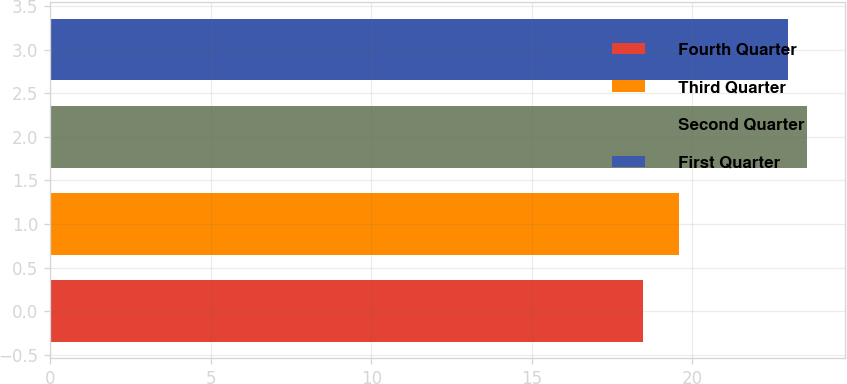Convert chart to OTSL. <chart><loc_0><loc_0><loc_500><loc_500><bar_chart><fcel>Fourth Quarter<fcel>Third Quarter<fcel>Second Quarter<fcel>First Quarter<nl><fcel>18.45<fcel>19.58<fcel>23.57<fcel>22.97<nl></chart> 